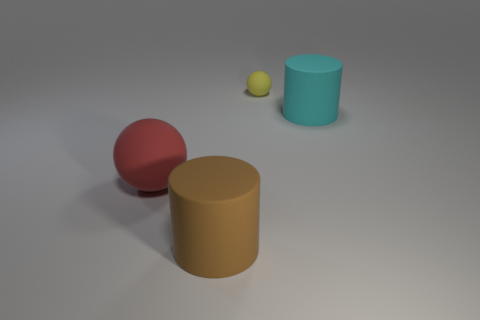Add 4 yellow shiny blocks. How many objects exist? 8 Subtract all cyan matte blocks. Subtract all big brown cylinders. How many objects are left? 3 Add 3 brown matte cylinders. How many brown matte cylinders are left? 4 Add 3 large purple matte things. How many large purple matte things exist? 3 Subtract 0 yellow blocks. How many objects are left? 4 